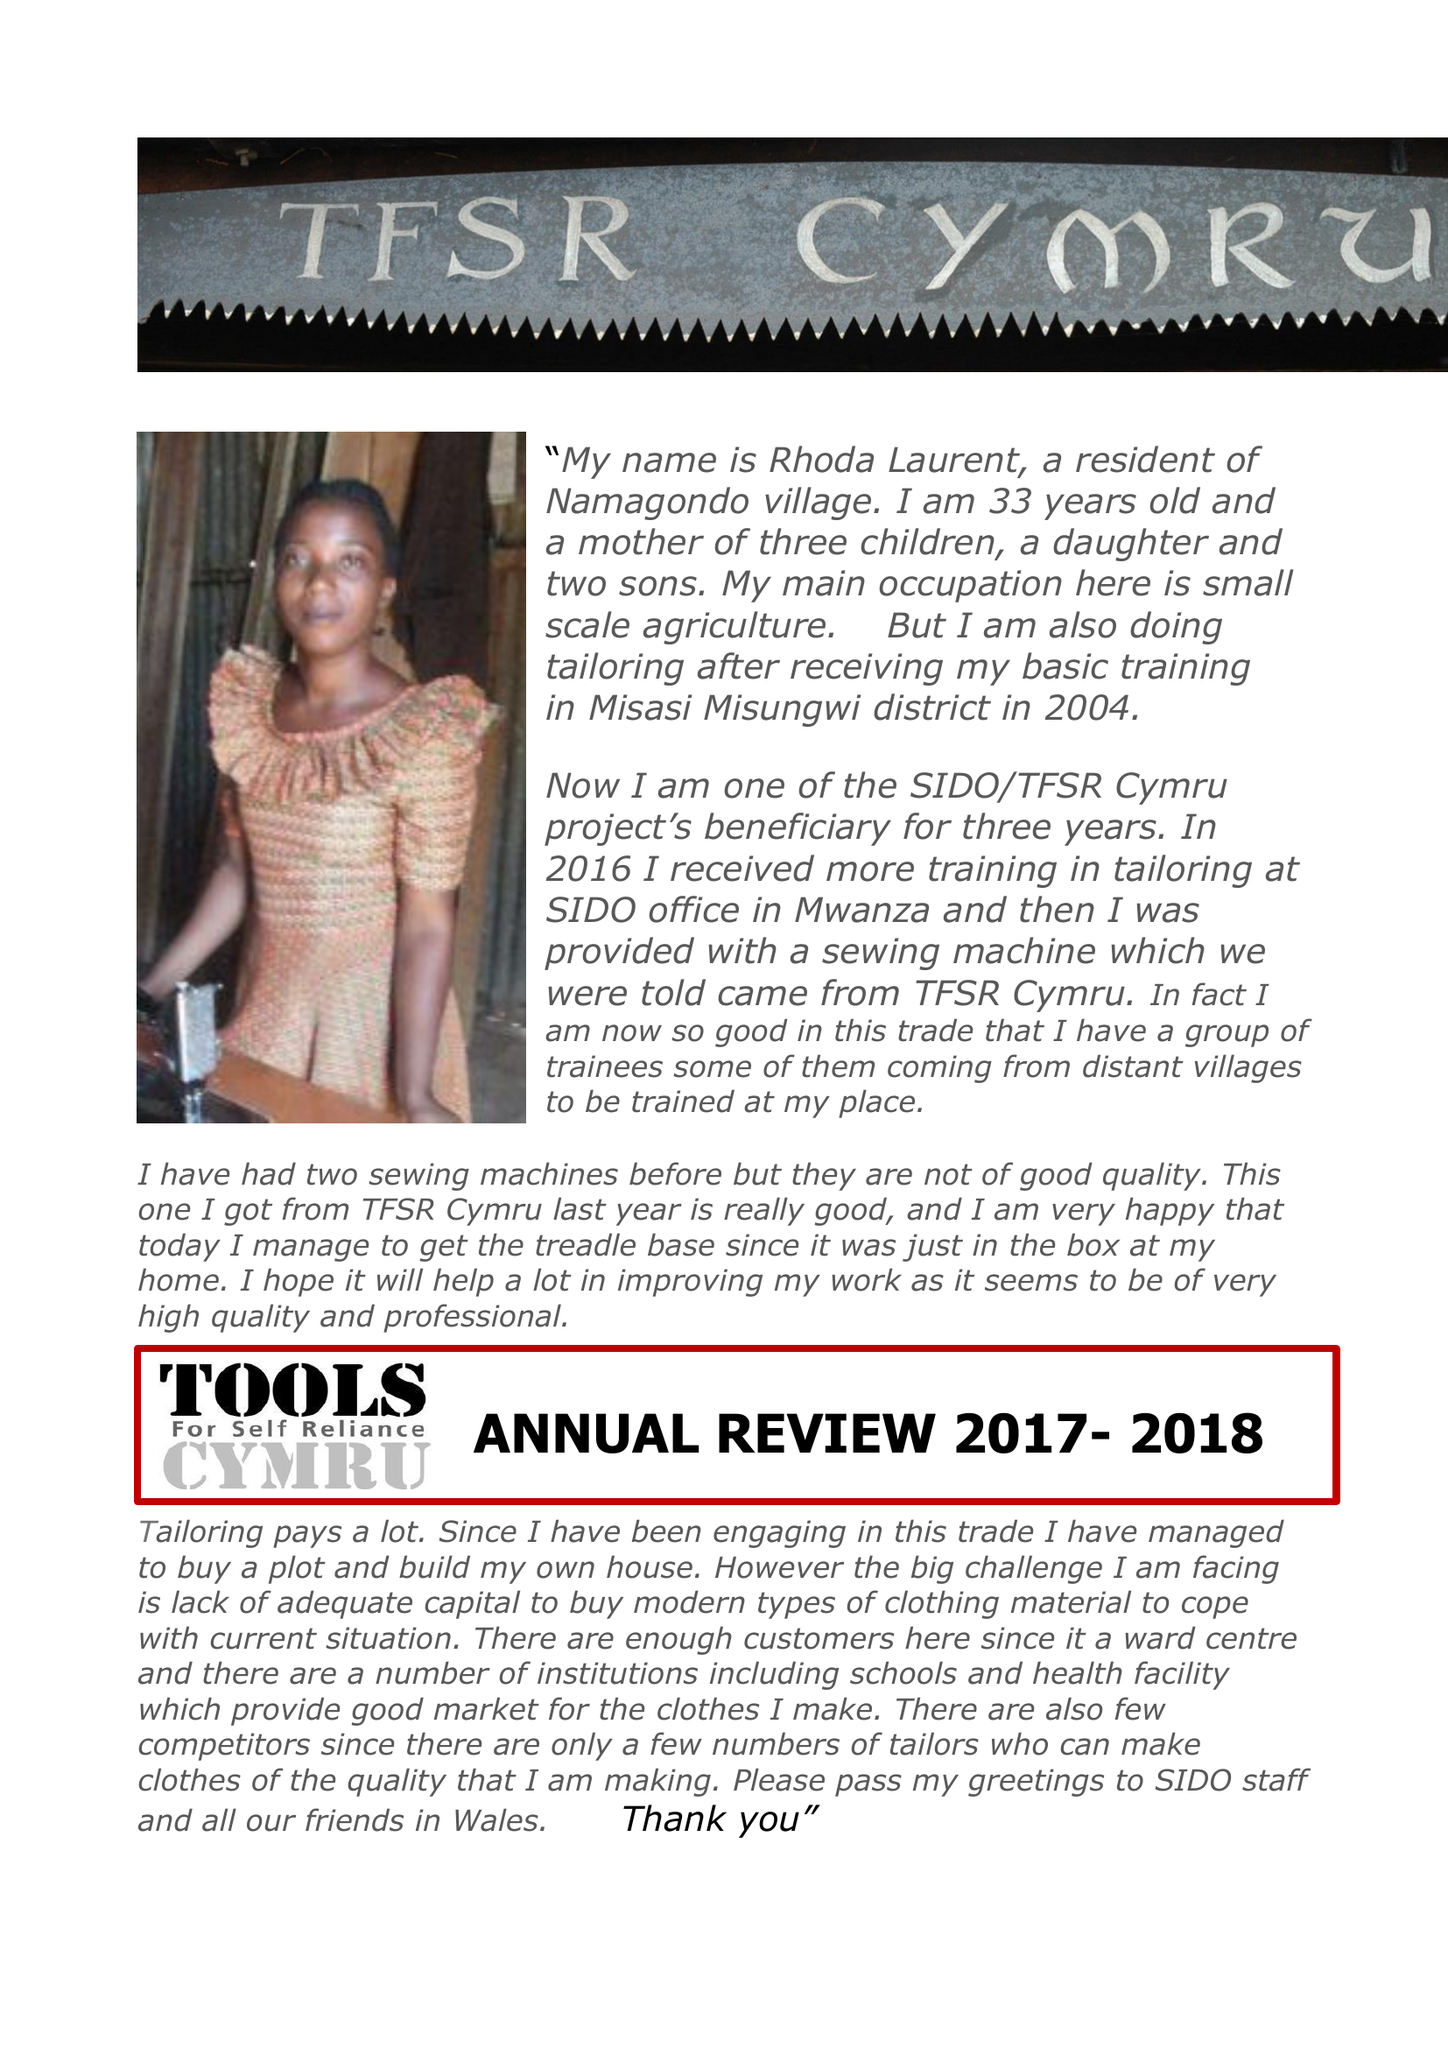What is the value for the address__street_line?
Answer the question using a single word or phrase. None 